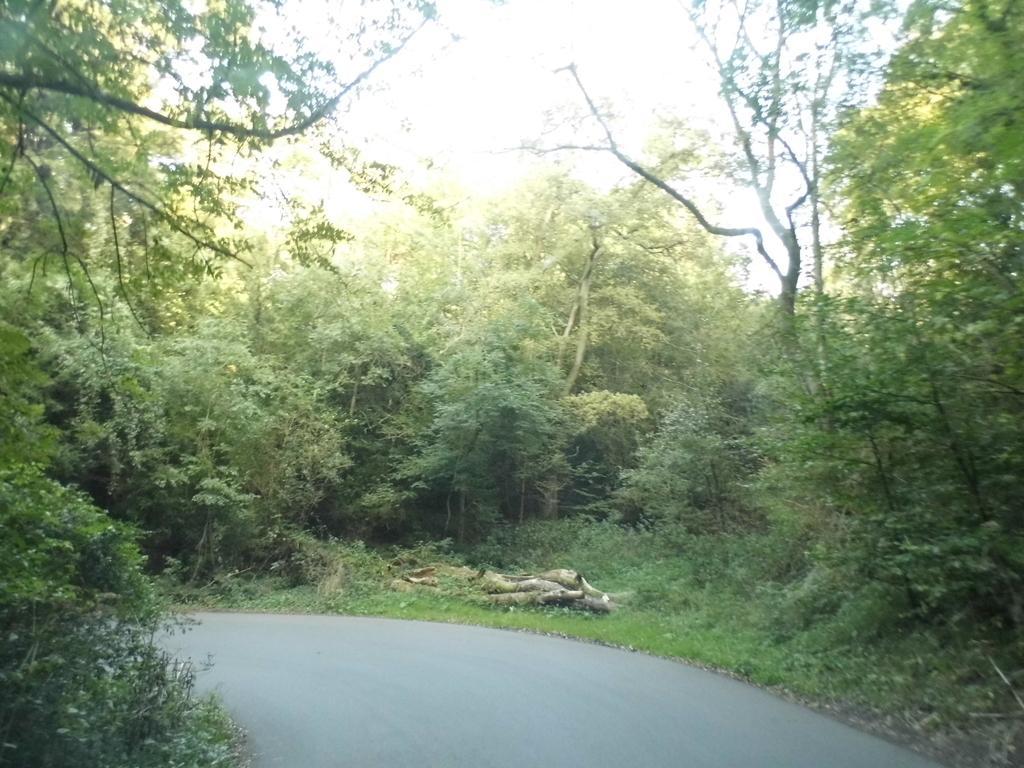Can you describe this image briefly? In the foreground of the picture there are plants, grass and road. In the center of the picture there are trees, plants and wood. 